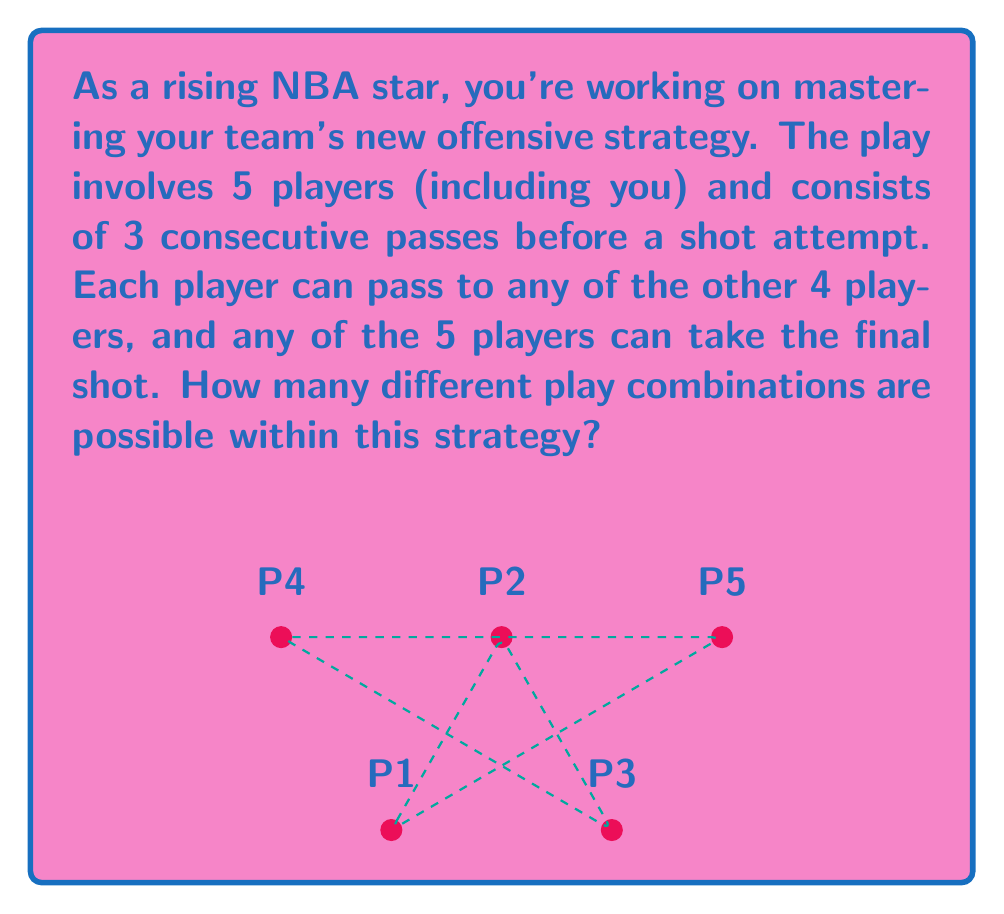Teach me how to tackle this problem. Let's break this down step-by-step:

1) First Pass: The player with the ball has 4 options to pass to.

2) Second Pass: After the first pass, the player who received the ball now has 4 options (including passing back to the original player).

3) Third Pass: Similarly, the third pass also has 4 options.

4) Final Shot: After the three passes, any of the 5 players can take the shot.

To calculate the total number of combinations, we multiply these options together:

$$ \text{Total Combinations} = 4 \times 4 \times 4 \times 5 $$

This is because for each choice of the first pass, we have all possibilities for the second pass, and so on. This is the fundamental counting principle.

Calculating:

$$ \text{Total Combinations} = 4 \times 4 \times 4 \times 5 = 4^3 \times 5 = 64 \times 5 = 320 $$

Therefore, there are 320 different play combinations possible within this offensive strategy.
Answer: 320 